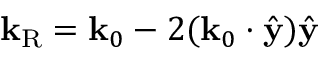<formula> <loc_0><loc_0><loc_500><loc_500>k _ { R } = k _ { 0 } - 2 ( k _ { 0 } \cdot \hat { y } ) \hat { y }</formula> 